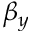Convert formula to latex. <formula><loc_0><loc_0><loc_500><loc_500>\beta _ { y }</formula> 